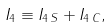<formula> <loc_0><loc_0><loc_500><loc_500>I _ { 4 } \equiv I _ { 4 \, S } + I _ { 4 \, C } ,</formula> 